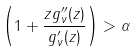Convert formula to latex. <formula><loc_0><loc_0><loc_500><loc_500>\real \left ( 1 + \frac { z g _ { \nu } ^ { \prime \prime } ( z ) } { g _ { \nu } ^ { \prime } ( z ) } \right ) > \alpha</formula> 